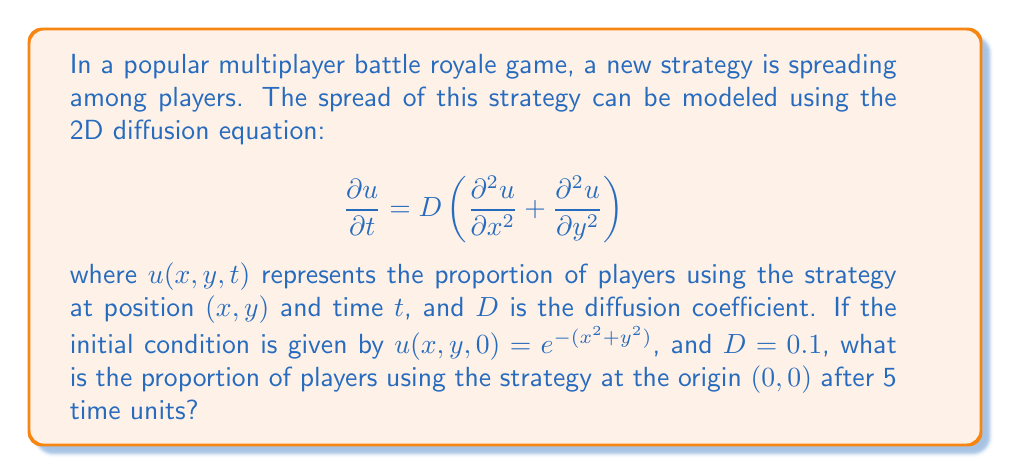Teach me how to tackle this problem. To solve this problem, we'll follow these steps:

1) The general solution to the 2D diffusion equation with an initial condition $u(x,y,0) = f(x,y)$ is:

   $$u(x,y,t) = \frac{1}{4\pi Dt} \iint_{-\infty}^{\infty} f(\xi,\eta) e^{-\frac{(x-\xi)^2+(y-\eta)^2}{4Dt}} d\xi d\eta$$

2) In our case, $f(x,y) = e^{-(x^2+y^2)}$, $D = 0.1$, and we're interested in $u(0,0,5)$.

3) Substituting these values:

   $$u(0,0,5) = \frac{1}{4\pi(0.1)(5)} \iint_{-\infty}^{\infty} e^{-(\xi^2+\eta^2)} e^{-\frac{(0-\xi)^2+(0-\eta)^2}{4(0.1)(5)}} d\xi d\eta$$

4) Simplify:

   $$u(0,0,5) = \frac{1}{2\pi} \iint_{-\infty}^{\infty} e^{-(\xi^2+\eta^2)} e^{-\frac{\xi^2+\eta^2}{2}} d\xi d\eta$$

5) Combine exponents:

   $$u(0,0,5) = \frac{1}{2\pi} \iint_{-\infty}^{\infty} e^{-\frac{3}{2}(\xi^2+\eta^2)} d\xi d\eta$$

6) This integral can be separated:

   $$u(0,0,5) = \frac{1}{2\pi} \left(\int_{-\infty}^{\infty} e^{-\frac{3}{2}\xi^2} d\xi\right) \left(\int_{-\infty}^{\infty} e^{-\frac{3}{2}\eta^2} d\eta\right)$$

7) Each integral is of the form $\int_{-\infty}^{\infty} e^{-ax^2} dx = \sqrt{\frac{\pi}{a}}$. Therefore:

   $$u(0,0,5) = \frac{1}{2\pi} \left(\sqrt{\frac{2\pi}{3}}\right) \left(\sqrt{\frac{2\pi}{3}}\right) = \frac{1}{3}$$

Thus, after 5 time units, the proportion of players using the strategy at the origin is $\frac{1}{3}$.
Answer: $\frac{1}{3}$ 